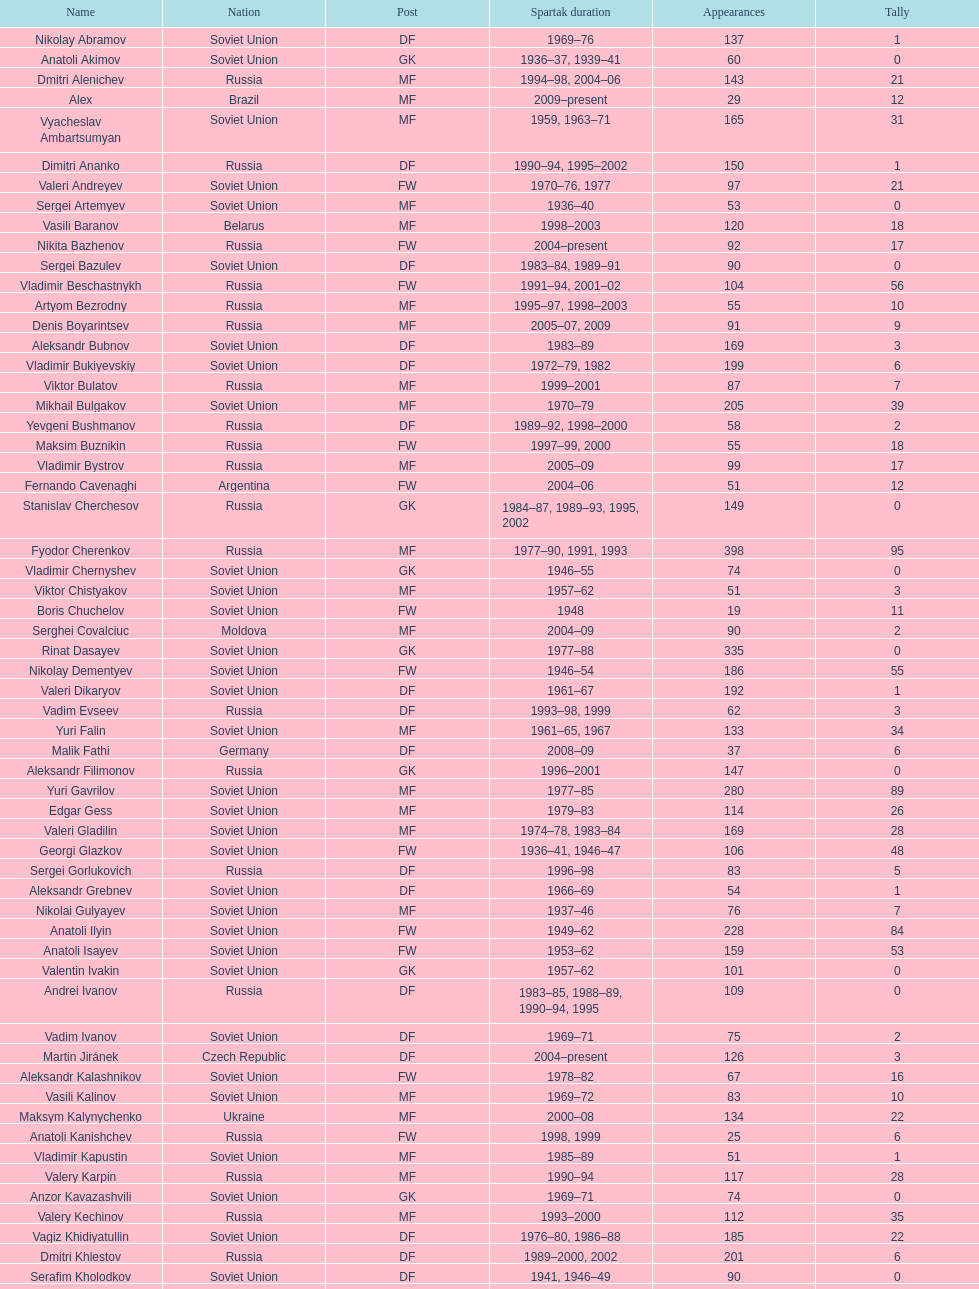Which player has the highest number of goals? Nikita Simonyan. 